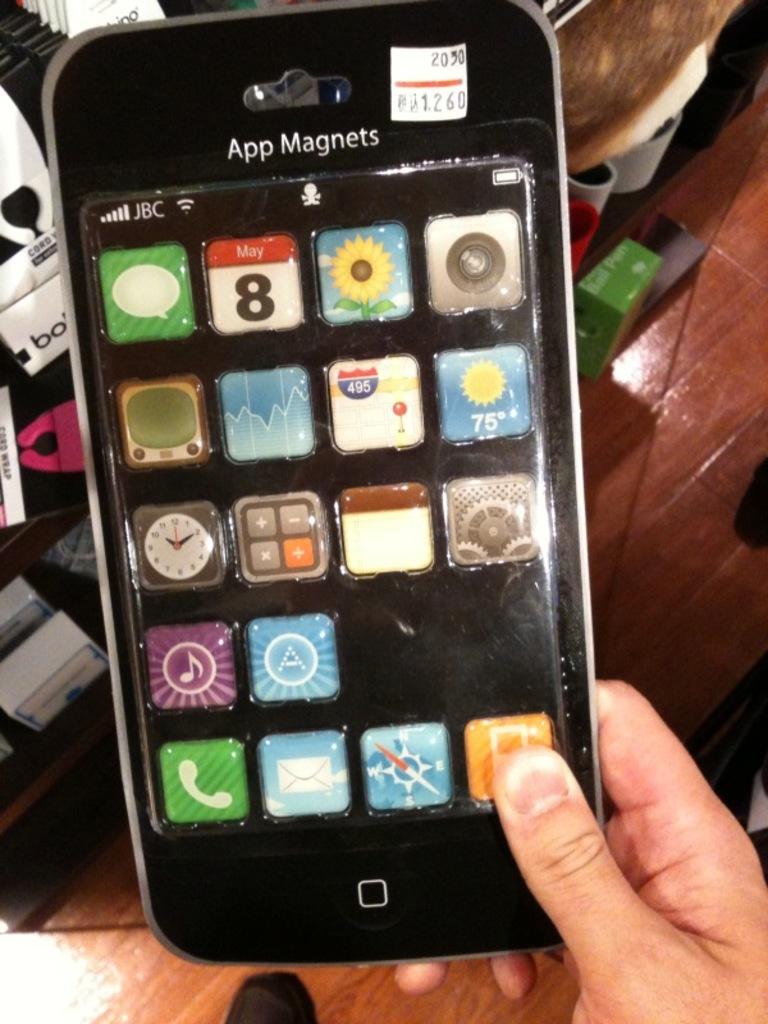What kind of magnets are these?
Provide a short and direct response. App. 